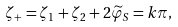Convert formula to latex. <formula><loc_0><loc_0><loc_500><loc_500>\zeta _ { + } = \zeta _ { 1 } + \zeta _ { 2 } + 2 \widetilde { \varphi } _ { S } = k \pi ,</formula> 